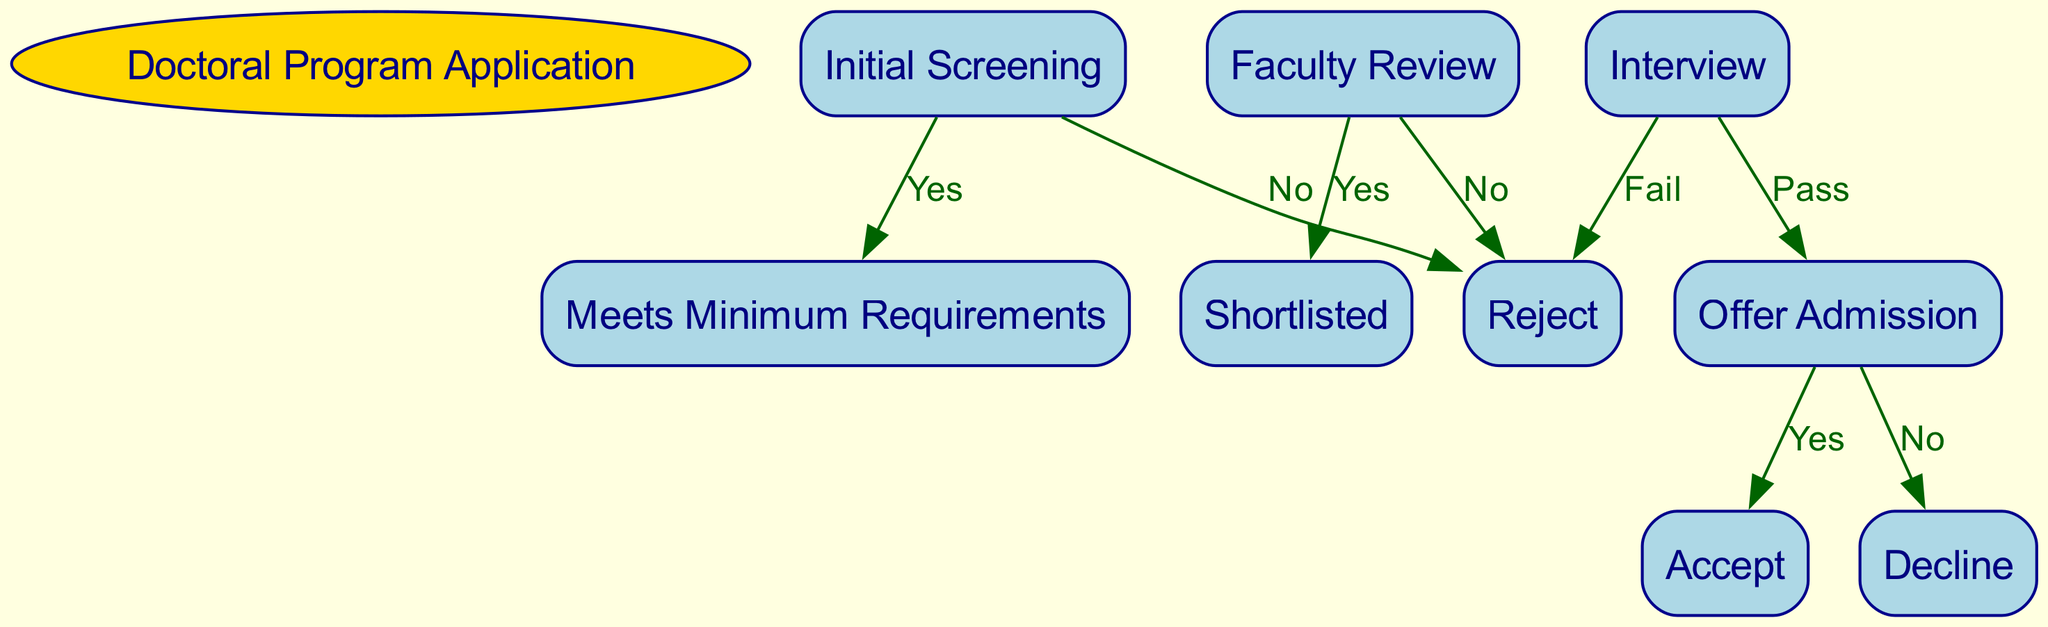What is the initial step in the doctoral program application process? The diagram starts with the "Initial Screening" node, which is the first step in the decision-making process for the doctoral program application.
Answer: Initial Screening How many decision points are there before offering admission? The diagram outlines four key decision points: Initial Screening, Faculty Review, Interview, and Offer Admission, mapping the process from application review to admission decision.
Answer: Four What happens if a student does not meet minimum requirements during Initial Screening? If the student does not meet the minimum requirements during Initial Screening, they will be directed to the "Reject" node, indicating their application will be unsuccessful.
Answer: Reject What is the outcome if a candidate fails the interview? If a candidate fails during the "Interview" stage, they are directed to the "Reject" node, resulting in the denial of their admission to the doctoral program.
Answer: Reject What are the two choices a candidate has after receiving an offer of admission? After receiving an offer of admission, a candidate can either "Accept" or "Decline" the offer, providing them with two distinct courses of action regarding their admission.
Answer: Accept, Decline How does one become shortlisted after the faculty review? A candidate becomes shortlisted after successfully passing the "Faculty Review," which is contingent upon meeting the evaluation criteria set by the faculty.
Answer: Shortlisted Which node indicates a definitive end to an application process? The "Reject" node signifies a definitive end to the application process, as it denotes that the candidate will not be admitted to the program at any stage.
Answer: Reject What follows if a candidate is shortlisted? If a candidate is shortlisted, the next step in the process is the "Interview," which is a critical stage leading to the admission decision.
Answer: Interview What is the nature of the relationship between the "Interview" and "Offer Admission" nodes? The "Interview" node has a decision point that leads to either a successful outcome, resulting in "Offer Admission" if the candidate passes, or a rejection if they fail.
Answer: Pass or Fail What is the label on the edge leading from "Faculty Review" to "Shortlisted"? The edge from "Faculty Review" to "Shortlisted" is labeled "Yes," indicating that a positive evaluation in the faculty review is required to proceed.
Answer: Yes 